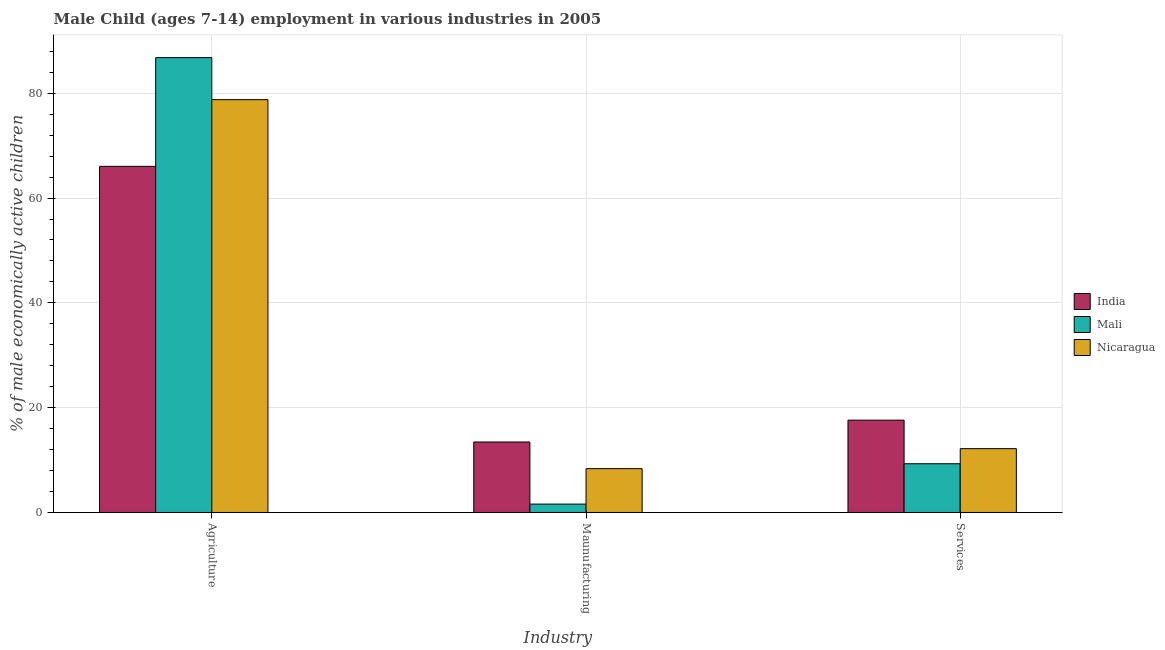How many different coloured bars are there?
Ensure brevity in your answer.  3. Are the number of bars on each tick of the X-axis equal?
Your answer should be very brief. Yes. How many bars are there on the 3rd tick from the left?
Give a very brief answer. 3. What is the label of the 3rd group of bars from the left?
Your answer should be compact. Services. What is the percentage of economically active children in agriculture in Nicaragua?
Your response must be concise. 78.78. Across all countries, what is the maximum percentage of economically active children in manufacturing?
Offer a terse response. 13.45. In which country was the percentage of economically active children in manufacturing maximum?
Provide a short and direct response. India. In which country was the percentage of economically active children in agriculture minimum?
Make the answer very short. India. What is the total percentage of economically active children in agriculture in the graph?
Your answer should be compact. 231.63. What is the difference between the percentage of economically active children in agriculture in Mali and that in Nicaragua?
Give a very brief answer. 8.02. What is the difference between the percentage of economically active children in services in Mali and the percentage of economically active children in manufacturing in India?
Make the answer very short. -4.15. What is the average percentage of economically active children in manufacturing per country?
Give a very brief answer. 7.8. What is the difference between the percentage of economically active children in manufacturing and percentage of economically active children in services in India?
Your response must be concise. -4.17. In how many countries, is the percentage of economically active children in manufacturing greater than 4 %?
Your response must be concise. 2. What is the ratio of the percentage of economically active children in services in Nicaragua to that in India?
Provide a short and direct response. 0.69. Is the percentage of economically active children in services in Mali less than that in Nicaragua?
Your response must be concise. Yes. Is the difference between the percentage of economically active children in manufacturing in Nicaragua and India greater than the difference between the percentage of economically active children in agriculture in Nicaragua and India?
Offer a terse response. No. What is the difference between the highest and the second highest percentage of economically active children in agriculture?
Your response must be concise. 8.02. What is the difference between the highest and the lowest percentage of economically active children in agriculture?
Your answer should be compact. 20.75. Is the sum of the percentage of economically active children in services in Mali and Nicaragua greater than the maximum percentage of economically active children in manufacturing across all countries?
Provide a succinct answer. Yes. What does the 3rd bar from the left in Agriculture represents?
Provide a succinct answer. Nicaragua. What does the 1st bar from the right in Maunufacturing represents?
Your answer should be compact. Nicaragua. Is it the case that in every country, the sum of the percentage of economically active children in agriculture and percentage of economically active children in manufacturing is greater than the percentage of economically active children in services?
Your response must be concise. Yes. Are all the bars in the graph horizontal?
Give a very brief answer. No. How many countries are there in the graph?
Make the answer very short. 3. What is the difference between two consecutive major ticks on the Y-axis?
Your response must be concise. 20. Does the graph contain any zero values?
Keep it short and to the point. No. Does the graph contain grids?
Give a very brief answer. Yes. How many legend labels are there?
Give a very brief answer. 3. How are the legend labels stacked?
Offer a terse response. Vertical. What is the title of the graph?
Keep it short and to the point. Male Child (ages 7-14) employment in various industries in 2005. Does "United Kingdom" appear as one of the legend labels in the graph?
Ensure brevity in your answer.  No. What is the label or title of the X-axis?
Keep it short and to the point. Industry. What is the label or title of the Y-axis?
Make the answer very short. % of male economically active children. What is the % of male economically active children of India in Agriculture?
Provide a short and direct response. 66.05. What is the % of male economically active children in Mali in Agriculture?
Keep it short and to the point. 86.8. What is the % of male economically active children in Nicaragua in Agriculture?
Provide a succinct answer. 78.78. What is the % of male economically active children of India in Maunufacturing?
Your answer should be compact. 13.45. What is the % of male economically active children in Mali in Maunufacturing?
Make the answer very short. 1.6. What is the % of male economically active children of Nicaragua in Maunufacturing?
Your answer should be very brief. 8.36. What is the % of male economically active children of India in Services?
Your answer should be very brief. 17.62. What is the % of male economically active children of Mali in Services?
Ensure brevity in your answer.  9.3. What is the % of male economically active children of Nicaragua in Services?
Keep it short and to the point. 12.18. Across all Industry, what is the maximum % of male economically active children in India?
Keep it short and to the point. 66.05. Across all Industry, what is the maximum % of male economically active children in Mali?
Your answer should be compact. 86.8. Across all Industry, what is the maximum % of male economically active children of Nicaragua?
Your answer should be compact. 78.78. Across all Industry, what is the minimum % of male economically active children in India?
Offer a very short reply. 13.45. Across all Industry, what is the minimum % of male economically active children of Nicaragua?
Ensure brevity in your answer.  8.36. What is the total % of male economically active children of India in the graph?
Ensure brevity in your answer.  97.12. What is the total % of male economically active children in Mali in the graph?
Make the answer very short. 97.7. What is the total % of male economically active children in Nicaragua in the graph?
Your response must be concise. 99.32. What is the difference between the % of male economically active children in India in Agriculture and that in Maunufacturing?
Provide a succinct answer. 52.6. What is the difference between the % of male economically active children of Mali in Agriculture and that in Maunufacturing?
Offer a very short reply. 85.2. What is the difference between the % of male economically active children in Nicaragua in Agriculture and that in Maunufacturing?
Your answer should be compact. 70.42. What is the difference between the % of male economically active children in India in Agriculture and that in Services?
Offer a very short reply. 48.43. What is the difference between the % of male economically active children in Mali in Agriculture and that in Services?
Give a very brief answer. 77.5. What is the difference between the % of male economically active children in Nicaragua in Agriculture and that in Services?
Provide a succinct answer. 66.6. What is the difference between the % of male economically active children in India in Maunufacturing and that in Services?
Provide a short and direct response. -4.17. What is the difference between the % of male economically active children in Mali in Maunufacturing and that in Services?
Your answer should be compact. -7.7. What is the difference between the % of male economically active children in Nicaragua in Maunufacturing and that in Services?
Keep it short and to the point. -3.82. What is the difference between the % of male economically active children in India in Agriculture and the % of male economically active children in Mali in Maunufacturing?
Ensure brevity in your answer.  64.45. What is the difference between the % of male economically active children in India in Agriculture and the % of male economically active children in Nicaragua in Maunufacturing?
Provide a succinct answer. 57.69. What is the difference between the % of male economically active children of Mali in Agriculture and the % of male economically active children of Nicaragua in Maunufacturing?
Give a very brief answer. 78.44. What is the difference between the % of male economically active children in India in Agriculture and the % of male economically active children in Mali in Services?
Provide a succinct answer. 56.75. What is the difference between the % of male economically active children of India in Agriculture and the % of male economically active children of Nicaragua in Services?
Give a very brief answer. 53.87. What is the difference between the % of male economically active children in Mali in Agriculture and the % of male economically active children in Nicaragua in Services?
Ensure brevity in your answer.  74.62. What is the difference between the % of male economically active children in India in Maunufacturing and the % of male economically active children in Mali in Services?
Keep it short and to the point. 4.15. What is the difference between the % of male economically active children in India in Maunufacturing and the % of male economically active children in Nicaragua in Services?
Make the answer very short. 1.27. What is the difference between the % of male economically active children in Mali in Maunufacturing and the % of male economically active children in Nicaragua in Services?
Your answer should be compact. -10.58. What is the average % of male economically active children of India per Industry?
Keep it short and to the point. 32.37. What is the average % of male economically active children in Mali per Industry?
Provide a succinct answer. 32.57. What is the average % of male economically active children of Nicaragua per Industry?
Your response must be concise. 33.11. What is the difference between the % of male economically active children of India and % of male economically active children of Mali in Agriculture?
Keep it short and to the point. -20.75. What is the difference between the % of male economically active children in India and % of male economically active children in Nicaragua in Agriculture?
Your answer should be compact. -12.73. What is the difference between the % of male economically active children in Mali and % of male economically active children in Nicaragua in Agriculture?
Your answer should be very brief. 8.02. What is the difference between the % of male economically active children of India and % of male economically active children of Mali in Maunufacturing?
Your answer should be compact. 11.85. What is the difference between the % of male economically active children in India and % of male economically active children in Nicaragua in Maunufacturing?
Keep it short and to the point. 5.09. What is the difference between the % of male economically active children in Mali and % of male economically active children in Nicaragua in Maunufacturing?
Ensure brevity in your answer.  -6.76. What is the difference between the % of male economically active children of India and % of male economically active children of Mali in Services?
Provide a succinct answer. 8.32. What is the difference between the % of male economically active children in India and % of male economically active children in Nicaragua in Services?
Offer a very short reply. 5.44. What is the difference between the % of male economically active children in Mali and % of male economically active children in Nicaragua in Services?
Provide a succinct answer. -2.88. What is the ratio of the % of male economically active children of India in Agriculture to that in Maunufacturing?
Your answer should be very brief. 4.91. What is the ratio of the % of male economically active children in Mali in Agriculture to that in Maunufacturing?
Your answer should be very brief. 54.25. What is the ratio of the % of male economically active children of Nicaragua in Agriculture to that in Maunufacturing?
Offer a terse response. 9.42. What is the ratio of the % of male economically active children in India in Agriculture to that in Services?
Keep it short and to the point. 3.75. What is the ratio of the % of male economically active children of Mali in Agriculture to that in Services?
Make the answer very short. 9.33. What is the ratio of the % of male economically active children in Nicaragua in Agriculture to that in Services?
Offer a terse response. 6.47. What is the ratio of the % of male economically active children in India in Maunufacturing to that in Services?
Your answer should be compact. 0.76. What is the ratio of the % of male economically active children of Mali in Maunufacturing to that in Services?
Offer a very short reply. 0.17. What is the ratio of the % of male economically active children of Nicaragua in Maunufacturing to that in Services?
Offer a terse response. 0.69. What is the difference between the highest and the second highest % of male economically active children in India?
Keep it short and to the point. 48.43. What is the difference between the highest and the second highest % of male economically active children of Mali?
Keep it short and to the point. 77.5. What is the difference between the highest and the second highest % of male economically active children in Nicaragua?
Offer a terse response. 66.6. What is the difference between the highest and the lowest % of male economically active children in India?
Offer a terse response. 52.6. What is the difference between the highest and the lowest % of male economically active children of Mali?
Keep it short and to the point. 85.2. What is the difference between the highest and the lowest % of male economically active children in Nicaragua?
Make the answer very short. 70.42. 